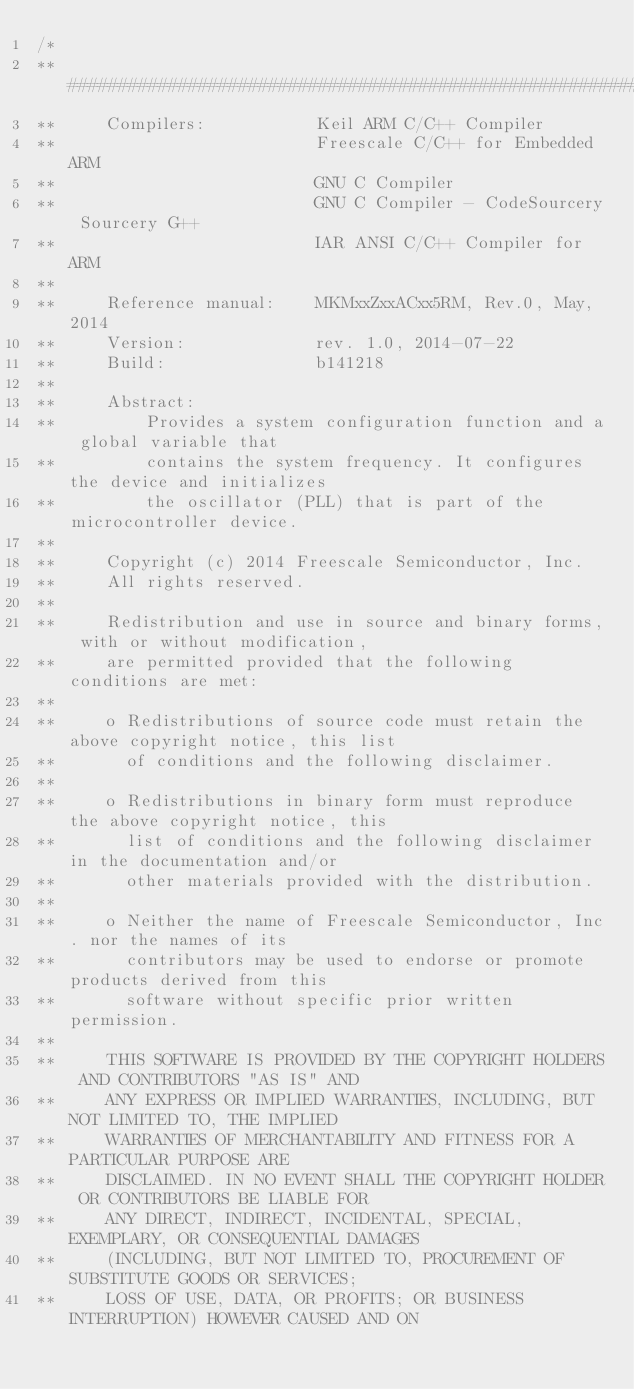<code> <loc_0><loc_0><loc_500><loc_500><_C_>/*
** ###################################################################
**     Compilers:           Keil ARM C/C++ Compiler
**                          Freescale C/C++ for Embedded ARM
**                          GNU C Compiler
**                          GNU C Compiler - CodeSourcery Sourcery G++
**                          IAR ANSI C/C++ Compiler for ARM
**
**     Reference manual:    MKMxxZxxACxx5RM, Rev.0, May, 2014
**     Version:             rev. 1.0, 2014-07-22
**     Build:               b141218
**
**     Abstract:
**         Provides a system configuration function and a global variable that
**         contains the system frequency. It configures the device and initializes
**         the oscillator (PLL) that is part of the microcontroller device.
**
**     Copyright (c) 2014 Freescale Semiconductor, Inc.
**     All rights reserved.
**
**     Redistribution and use in source and binary forms, with or without modification,
**     are permitted provided that the following conditions are met:
**
**     o Redistributions of source code must retain the above copyright notice, this list
**       of conditions and the following disclaimer.
**
**     o Redistributions in binary form must reproduce the above copyright notice, this
**       list of conditions and the following disclaimer in the documentation and/or
**       other materials provided with the distribution.
**
**     o Neither the name of Freescale Semiconductor, Inc. nor the names of its
**       contributors may be used to endorse or promote products derived from this
**       software without specific prior written permission.
**
**     THIS SOFTWARE IS PROVIDED BY THE COPYRIGHT HOLDERS AND CONTRIBUTORS "AS IS" AND
**     ANY EXPRESS OR IMPLIED WARRANTIES, INCLUDING, BUT NOT LIMITED TO, THE IMPLIED
**     WARRANTIES OF MERCHANTABILITY AND FITNESS FOR A PARTICULAR PURPOSE ARE
**     DISCLAIMED. IN NO EVENT SHALL THE COPYRIGHT HOLDER OR CONTRIBUTORS BE LIABLE FOR
**     ANY DIRECT, INDIRECT, INCIDENTAL, SPECIAL, EXEMPLARY, OR CONSEQUENTIAL DAMAGES
**     (INCLUDING, BUT NOT LIMITED TO, PROCUREMENT OF SUBSTITUTE GOODS OR SERVICES;
**     LOSS OF USE, DATA, OR PROFITS; OR BUSINESS INTERRUPTION) HOWEVER CAUSED AND ON</code> 